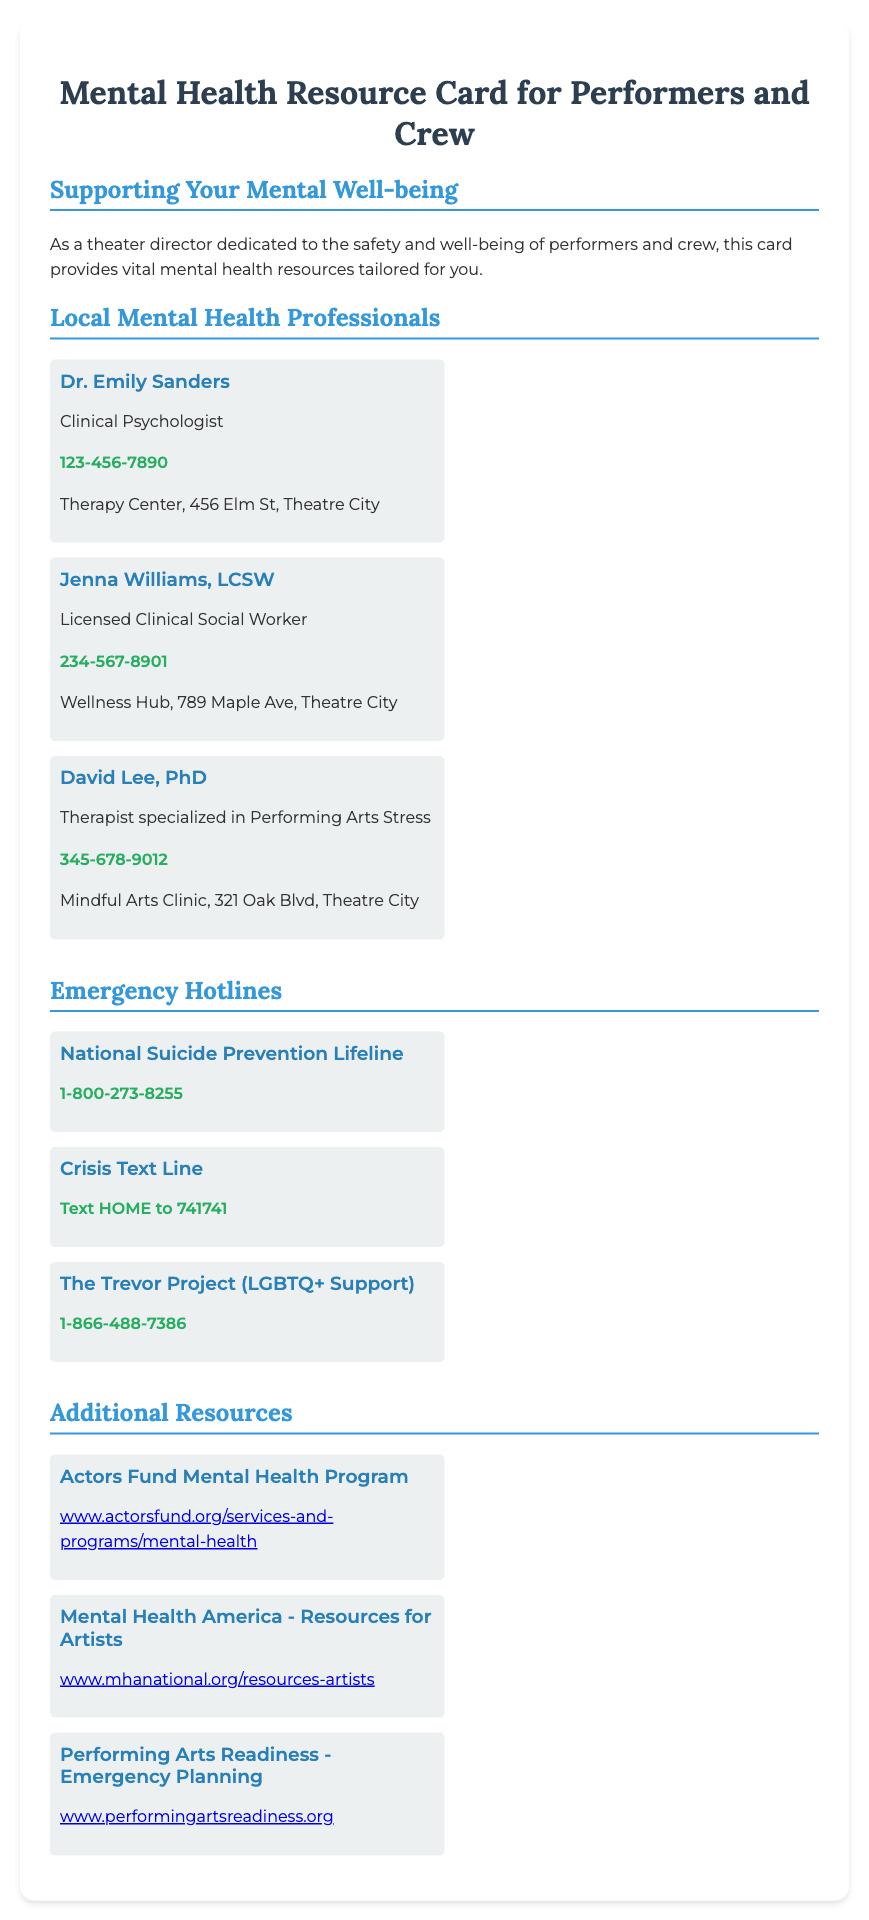What is the title of the card? The title of the card is presented prominently at the top of the document, indicating its purpose for performers and crew.
Answer: Mental Health Resource Card for Performers and Crew Who is the first listed mental health professional? The document provides names of local mental health professionals in a specific order, with the first being highlighted in the professionals' section.
Answer: Dr. Emily Sanders What is the contact number for Jenna Williams, LCSW? This question retrieves specific contact information listed under the mental health professionals section, which includes phone numbers.
Answer: 234-567-8901 How many emergency hotlines are listed in the card? The document features separate sections including one for emergency hotlines and counting these entries yields the answer.
Answer: 3 What is the first hotline's name? The first hotline is explicitly stated at the beginning of the emergency hotlines section of the card.
Answer: National Suicide Prevention Lifeline Which organization offers a Mental Health Program specifically for actors? This asks for the name of the program referenced in the resources section, focusing on the arts community.
Answer: Actors Fund Mental Health Program What mental health resource is tailored for LGBTQ+ individuals? This particular resource is aimed at a specific demographic, which is indicated clearly under the emergency hotlines.
Answer: The Trevor Project (LGBTQ+ Support) How many local mental health professionals are listed? By counting the entries in the local mental health professionals section, we can find the total number.
Answer: 3 